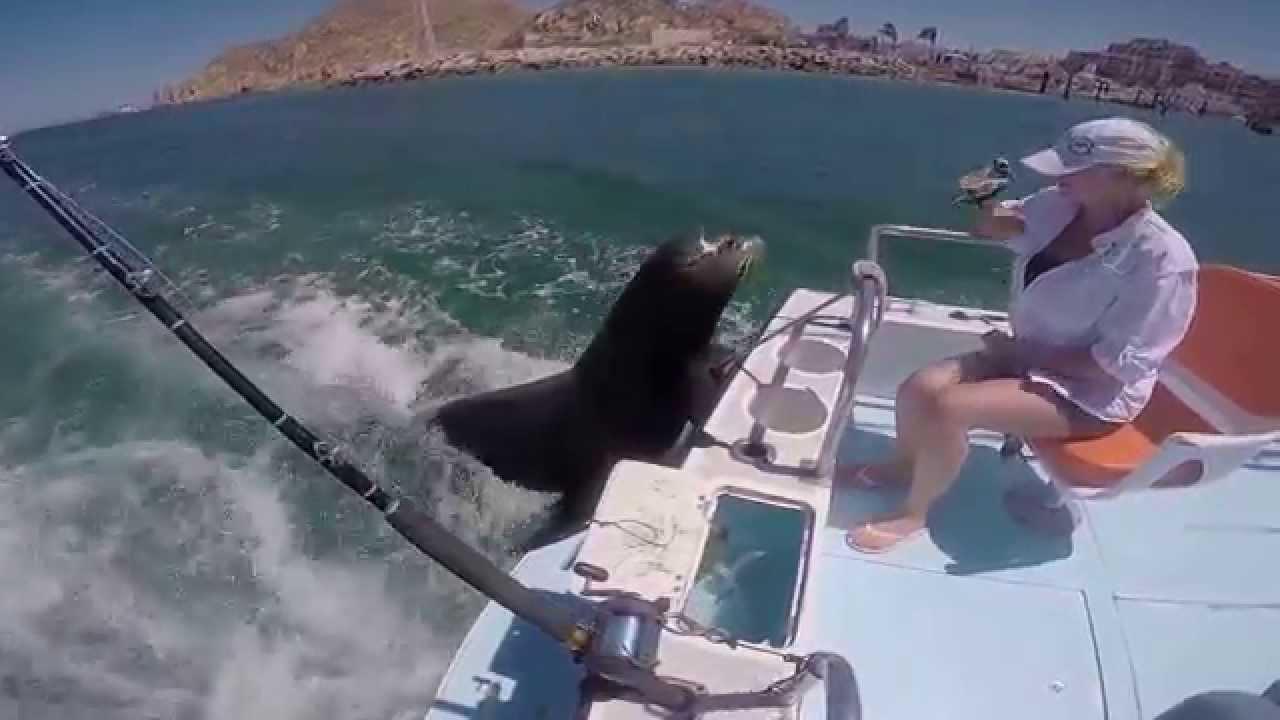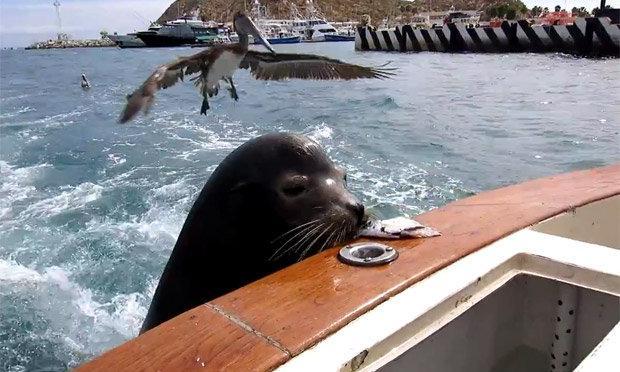The first image is the image on the left, the second image is the image on the right. Considering the images on both sides, is "The right image contains a person holding a fish." valid? Answer yes or no. No. The first image is the image on the left, the second image is the image on the right. Assess this claim about the two images: "A sea lion is looking over a boat where a woman sits.". Correct or not? Answer yes or no. Yes. 